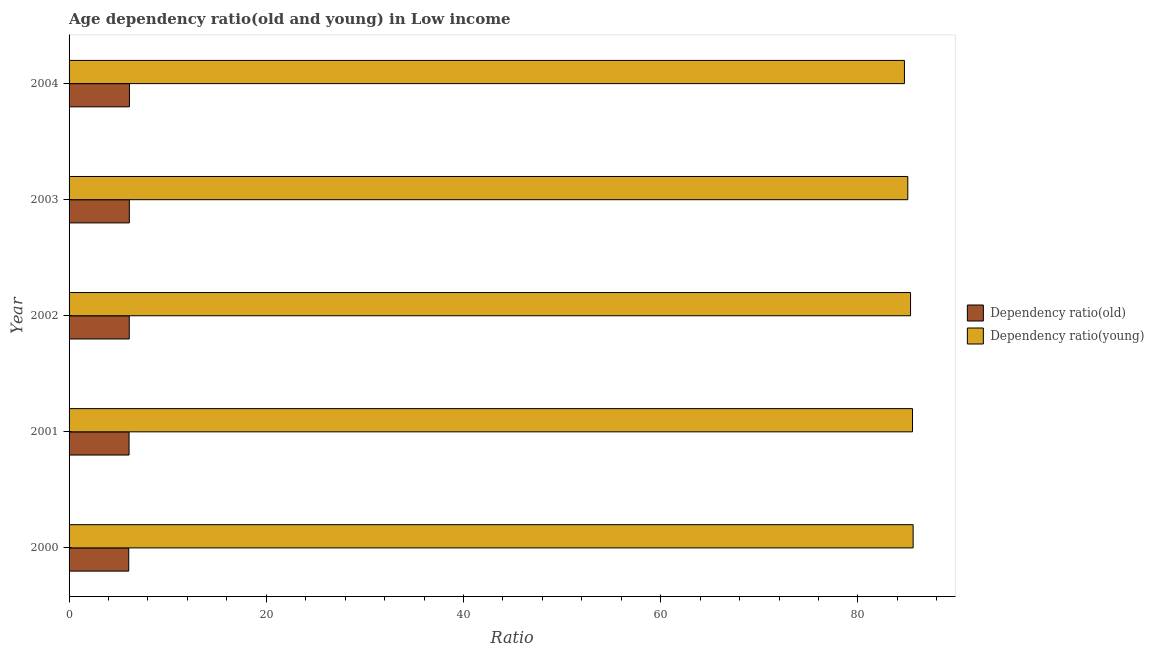How many different coloured bars are there?
Keep it short and to the point. 2. How many groups of bars are there?
Your response must be concise. 5. How many bars are there on the 1st tick from the bottom?
Give a very brief answer. 2. What is the label of the 4th group of bars from the top?
Provide a succinct answer. 2001. What is the age dependency ratio(young) in 2000?
Keep it short and to the point. 85.6. Across all years, what is the maximum age dependency ratio(old)?
Offer a terse response. 6.12. Across all years, what is the minimum age dependency ratio(young)?
Ensure brevity in your answer.  84.72. In which year was the age dependency ratio(young) maximum?
Offer a terse response. 2000. In which year was the age dependency ratio(young) minimum?
Provide a short and direct response. 2004. What is the total age dependency ratio(old) in the graph?
Your answer should be compact. 30.47. What is the difference between the age dependency ratio(old) in 2000 and that in 2004?
Provide a succinct answer. -0.07. What is the difference between the age dependency ratio(old) in 2001 and the age dependency ratio(young) in 2003?
Ensure brevity in your answer.  -78.97. What is the average age dependency ratio(old) per year?
Your response must be concise. 6.09. In the year 2001, what is the difference between the age dependency ratio(young) and age dependency ratio(old)?
Keep it short and to the point. 79.45. What is the ratio of the age dependency ratio(old) in 2000 to that in 2004?
Offer a very short reply. 0.99. Is the age dependency ratio(old) in 2000 less than that in 2002?
Ensure brevity in your answer.  Yes. What is the difference between the highest and the second highest age dependency ratio(old)?
Your response must be concise. 0.01. What is the difference between the highest and the lowest age dependency ratio(old)?
Your answer should be compact. 0.07. In how many years, is the age dependency ratio(young) greater than the average age dependency ratio(young) taken over all years?
Give a very brief answer. 3. Is the sum of the age dependency ratio(old) in 2003 and 2004 greater than the maximum age dependency ratio(young) across all years?
Offer a very short reply. No. What does the 1st bar from the top in 2000 represents?
Keep it short and to the point. Dependency ratio(young). What does the 1st bar from the bottom in 2000 represents?
Your answer should be compact. Dependency ratio(old). How many bars are there?
Ensure brevity in your answer.  10. Are all the bars in the graph horizontal?
Offer a very short reply. Yes. How many years are there in the graph?
Ensure brevity in your answer.  5. What is the difference between two consecutive major ticks on the X-axis?
Make the answer very short. 20. Are the values on the major ticks of X-axis written in scientific E-notation?
Provide a short and direct response. No. Where does the legend appear in the graph?
Your response must be concise. Center right. What is the title of the graph?
Your answer should be very brief. Age dependency ratio(old and young) in Low income. What is the label or title of the X-axis?
Offer a very short reply. Ratio. What is the label or title of the Y-axis?
Offer a very short reply. Year. What is the Ratio of Dependency ratio(old) in 2000?
Keep it short and to the point. 6.05. What is the Ratio in Dependency ratio(young) in 2000?
Offer a terse response. 85.6. What is the Ratio in Dependency ratio(old) in 2001?
Provide a succinct answer. 6.08. What is the Ratio of Dependency ratio(young) in 2001?
Offer a very short reply. 85.53. What is the Ratio in Dependency ratio(old) in 2002?
Your answer should be compact. 6.1. What is the Ratio in Dependency ratio(young) in 2002?
Provide a short and direct response. 85.34. What is the Ratio of Dependency ratio(old) in 2003?
Provide a succinct answer. 6.11. What is the Ratio of Dependency ratio(young) in 2003?
Your answer should be compact. 85.06. What is the Ratio of Dependency ratio(old) in 2004?
Give a very brief answer. 6.12. What is the Ratio in Dependency ratio(young) in 2004?
Your answer should be very brief. 84.72. Across all years, what is the maximum Ratio of Dependency ratio(old)?
Provide a short and direct response. 6.12. Across all years, what is the maximum Ratio of Dependency ratio(young)?
Make the answer very short. 85.6. Across all years, what is the minimum Ratio of Dependency ratio(old)?
Provide a short and direct response. 6.05. Across all years, what is the minimum Ratio of Dependency ratio(young)?
Keep it short and to the point. 84.72. What is the total Ratio of Dependency ratio(old) in the graph?
Provide a short and direct response. 30.47. What is the total Ratio of Dependency ratio(young) in the graph?
Provide a short and direct response. 426.25. What is the difference between the Ratio of Dependency ratio(old) in 2000 and that in 2001?
Your response must be concise. -0.03. What is the difference between the Ratio in Dependency ratio(young) in 2000 and that in 2001?
Ensure brevity in your answer.  0.07. What is the difference between the Ratio in Dependency ratio(old) in 2000 and that in 2002?
Make the answer very short. -0.05. What is the difference between the Ratio of Dependency ratio(young) in 2000 and that in 2002?
Offer a terse response. 0.26. What is the difference between the Ratio in Dependency ratio(old) in 2000 and that in 2003?
Your answer should be very brief. -0.06. What is the difference between the Ratio in Dependency ratio(young) in 2000 and that in 2003?
Your response must be concise. 0.54. What is the difference between the Ratio in Dependency ratio(old) in 2000 and that in 2004?
Offer a terse response. -0.07. What is the difference between the Ratio of Dependency ratio(young) in 2000 and that in 2004?
Your response must be concise. 0.88. What is the difference between the Ratio of Dependency ratio(old) in 2001 and that in 2002?
Provide a short and direct response. -0.02. What is the difference between the Ratio in Dependency ratio(young) in 2001 and that in 2002?
Your answer should be very brief. 0.2. What is the difference between the Ratio in Dependency ratio(old) in 2001 and that in 2003?
Keep it short and to the point. -0.03. What is the difference between the Ratio in Dependency ratio(young) in 2001 and that in 2003?
Give a very brief answer. 0.48. What is the difference between the Ratio in Dependency ratio(old) in 2001 and that in 2004?
Ensure brevity in your answer.  -0.04. What is the difference between the Ratio in Dependency ratio(young) in 2001 and that in 2004?
Provide a succinct answer. 0.82. What is the difference between the Ratio in Dependency ratio(old) in 2002 and that in 2003?
Provide a succinct answer. -0.01. What is the difference between the Ratio of Dependency ratio(young) in 2002 and that in 2003?
Provide a succinct answer. 0.28. What is the difference between the Ratio in Dependency ratio(old) in 2002 and that in 2004?
Your answer should be compact. -0.02. What is the difference between the Ratio in Dependency ratio(young) in 2002 and that in 2004?
Provide a succinct answer. 0.62. What is the difference between the Ratio of Dependency ratio(old) in 2003 and that in 2004?
Your answer should be compact. -0.01. What is the difference between the Ratio in Dependency ratio(young) in 2003 and that in 2004?
Provide a succinct answer. 0.34. What is the difference between the Ratio in Dependency ratio(old) in 2000 and the Ratio in Dependency ratio(young) in 2001?
Ensure brevity in your answer.  -79.48. What is the difference between the Ratio of Dependency ratio(old) in 2000 and the Ratio of Dependency ratio(young) in 2002?
Your response must be concise. -79.29. What is the difference between the Ratio of Dependency ratio(old) in 2000 and the Ratio of Dependency ratio(young) in 2003?
Your answer should be very brief. -79.01. What is the difference between the Ratio of Dependency ratio(old) in 2000 and the Ratio of Dependency ratio(young) in 2004?
Offer a terse response. -78.67. What is the difference between the Ratio of Dependency ratio(old) in 2001 and the Ratio of Dependency ratio(young) in 2002?
Provide a succinct answer. -79.25. What is the difference between the Ratio in Dependency ratio(old) in 2001 and the Ratio in Dependency ratio(young) in 2003?
Give a very brief answer. -78.97. What is the difference between the Ratio in Dependency ratio(old) in 2001 and the Ratio in Dependency ratio(young) in 2004?
Provide a short and direct response. -78.63. What is the difference between the Ratio of Dependency ratio(old) in 2002 and the Ratio of Dependency ratio(young) in 2003?
Offer a terse response. -78.95. What is the difference between the Ratio in Dependency ratio(old) in 2002 and the Ratio in Dependency ratio(young) in 2004?
Offer a terse response. -78.61. What is the difference between the Ratio of Dependency ratio(old) in 2003 and the Ratio of Dependency ratio(young) in 2004?
Your answer should be compact. -78.6. What is the average Ratio in Dependency ratio(old) per year?
Your answer should be compact. 6.09. What is the average Ratio of Dependency ratio(young) per year?
Your response must be concise. 85.25. In the year 2000, what is the difference between the Ratio in Dependency ratio(old) and Ratio in Dependency ratio(young)?
Offer a terse response. -79.55. In the year 2001, what is the difference between the Ratio of Dependency ratio(old) and Ratio of Dependency ratio(young)?
Make the answer very short. -79.45. In the year 2002, what is the difference between the Ratio in Dependency ratio(old) and Ratio in Dependency ratio(young)?
Offer a terse response. -79.23. In the year 2003, what is the difference between the Ratio of Dependency ratio(old) and Ratio of Dependency ratio(young)?
Offer a terse response. -78.94. In the year 2004, what is the difference between the Ratio of Dependency ratio(old) and Ratio of Dependency ratio(young)?
Give a very brief answer. -78.6. What is the ratio of the Ratio in Dependency ratio(old) in 2000 to that in 2001?
Ensure brevity in your answer.  0.99. What is the ratio of the Ratio of Dependency ratio(young) in 2000 to that in 2001?
Keep it short and to the point. 1. What is the ratio of the Ratio in Dependency ratio(young) in 2000 to that in 2003?
Keep it short and to the point. 1.01. What is the ratio of the Ratio of Dependency ratio(old) in 2000 to that in 2004?
Keep it short and to the point. 0.99. What is the ratio of the Ratio of Dependency ratio(young) in 2000 to that in 2004?
Ensure brevity in your answer.  1.01. What is the ratio of the Ratio of Dependency ratio(young) in 2001 to that in 2002?
Provide a succinct answer. 1. What is the ratio of the Ratio in Dependency ratio(old) in 2001 to that in 2003?
Your answer should be very brief. 1. What is the ratio of the Ratio in Dependency ratio(young) in 2001 to that in 2003?
Your answer should be very brief. 1.01. What is the ratio of the Ratio of Dependency ratio(young) in 2001 to that in 2004?
Offer a terse response. 1.01. What is the ratio of the Ratio of Dependency ratio(old) in 2002 to that in 2004?
Your answer should be very brief. 1. What is the ratio of the Ratio of Dependency ratio(young) in 2002 to that in 2004?
Offer a very short reply. 1.01. What is the difference between the highest and the second highest Ratio of Dependency ratio(old)?
Ensure brevity in your answer.  0.01. What is the difference between the highest and the second highest Ratio of Dependency ratio(young)?
Offer a terse response. 0.07. What is the difference between the highest and the lowest Ratio of Dependency ratio(old)?
Your answer should be compact. 0.07. What is the difference between the highest and the lowest Ratio in Dependency ratio(young)?
Make the answer very short. 0.88. 